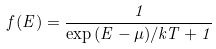Convert formula to latex. <formula><loc_0><loc_0><loc_500><loc_500>f ( E ) = \frac { 1 } { \exp \, ( E - \mu ) / k T + 1 }</formula> 